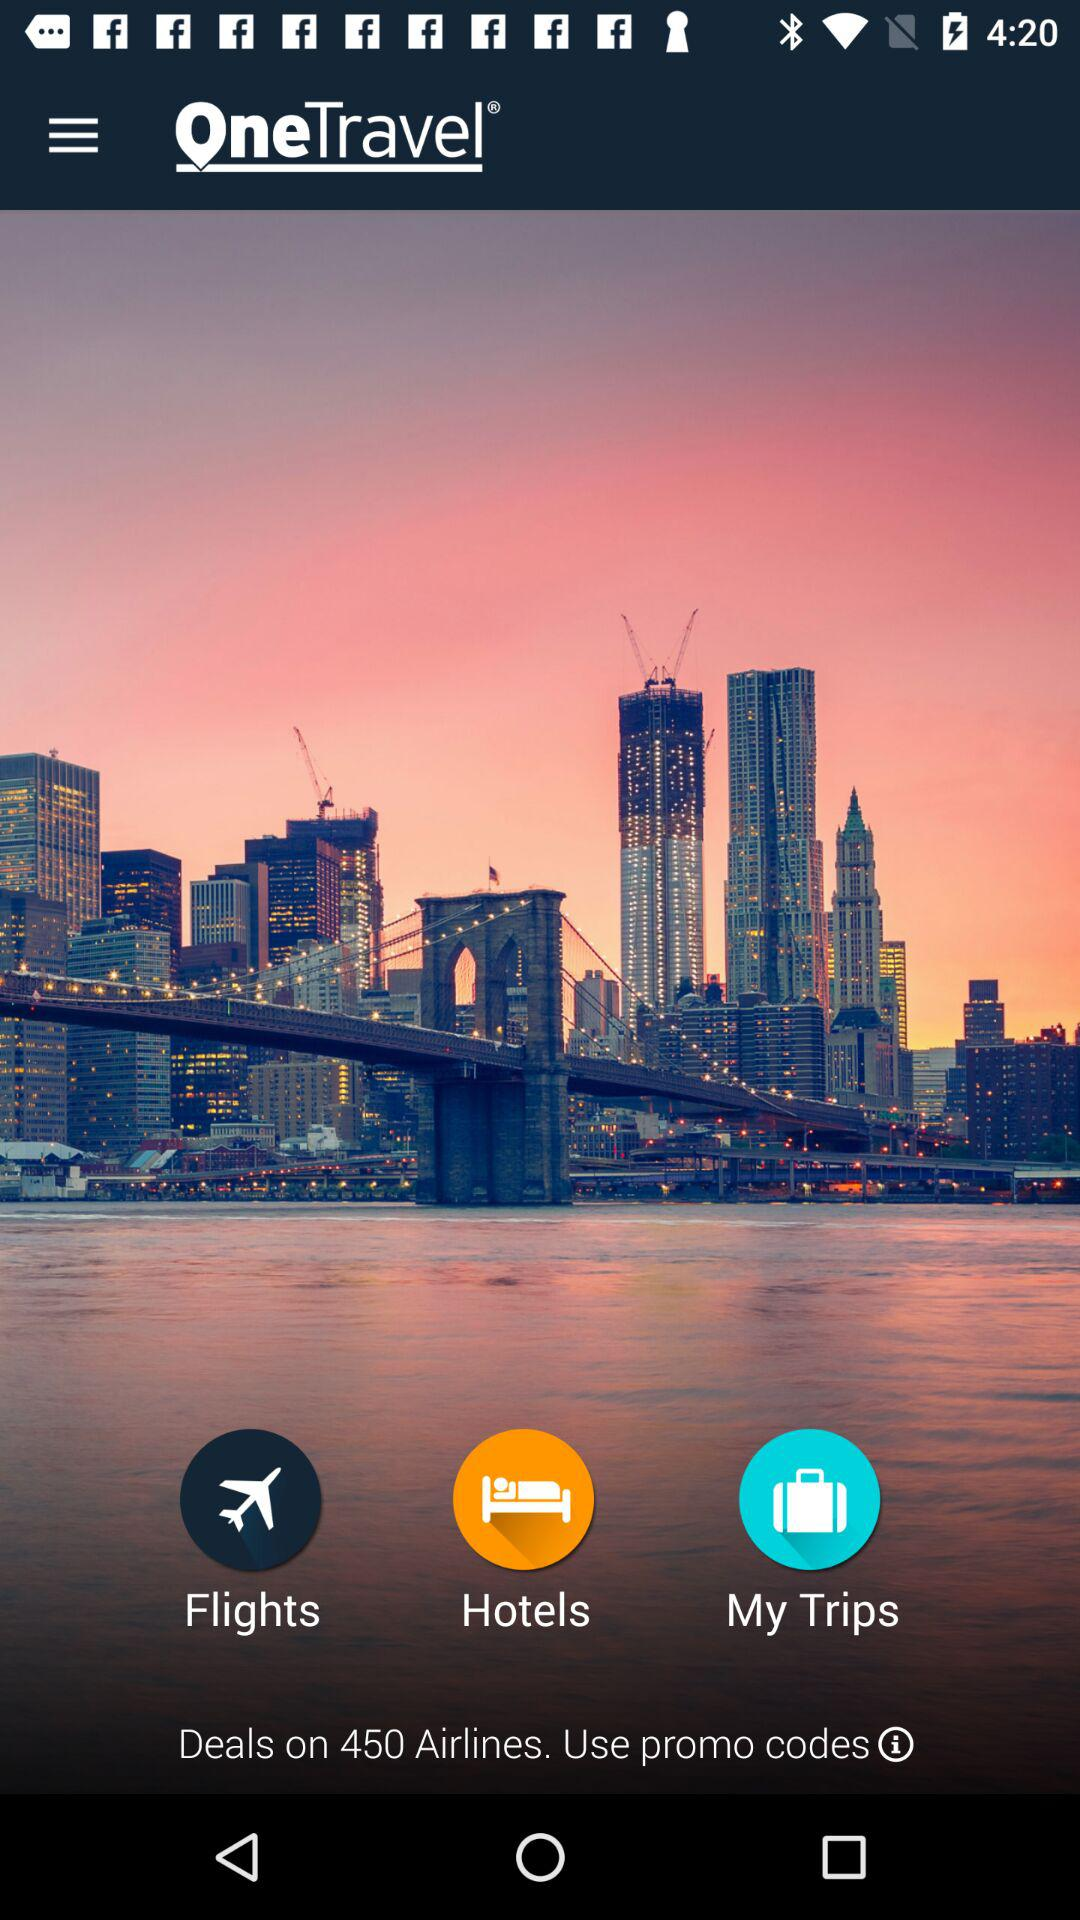On how many airlines are the deals available? The deals are available on 450 airlines. 